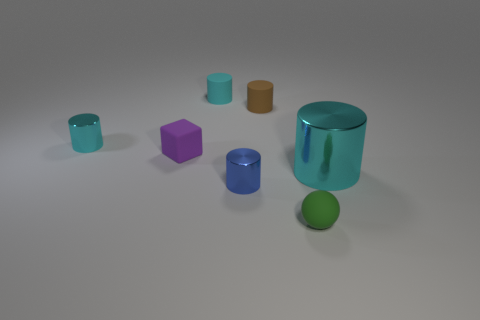How many objects are there in total and can you describe them by their colors and materials? There are seven objects in total. Starting from the left, there is a small cyan matte cylinder, a purple matte cube, a larger cyan shiny cylinder, a brown matte cylinder, and in front of these, a tiny cyan matte cylinder, a small orange matte cube, and a green spherical rubber object. 